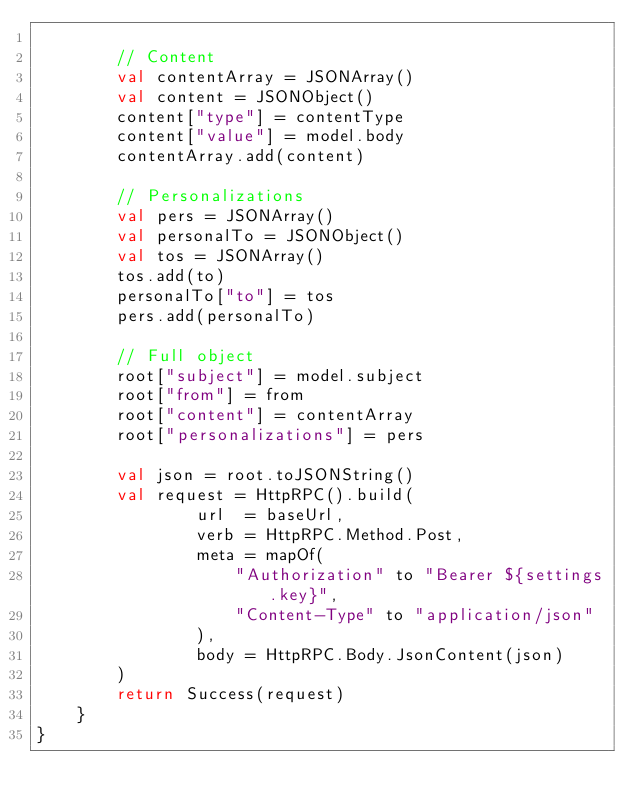Convert code to text. <code><loc_0><loc_0><loc_500><loc_500><_Kotlin_>
        // Content
        val contentArray = JSONArray()
        val content = JSONObject()
        content["type"] = contentType
        content["value"] = model.body
        contentArray.add(content)

        // Personalizations
        val pers = JSONArray()
        val personalTo = JSONObject()
        val tos = JSONArray()
        tos.add(to)
        personalTo["to"] = tos
        pers.add(personalTo)

        // Full object
        root["subject"] = model.subject
        root["from"] = from
        root["content"] = contentArray
        root["personalizations"] = pers

        val json = root.toJSONString()
        val request = HttpRPC().build(
                url  = baseUrl,
                verb = HttpRPC.Method.Post,
                meta = mapOf(
                    "Authorization" to "Bearer ${settings.key}",
                    "Content-Type" to "application/json"
                ),
                body = HttpRPC.Body.JsonContent(json)
        )
        return Success(request)
    }
}
</code> 